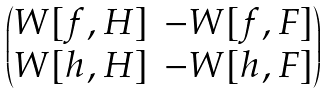<formula> <loc_0><loc_0><loc_500><loc_500>\begin{pmatrix} W [ f , H ] & - W [ f , F ] \\ W [ h , H ] & - W [ h , F ] \end{pmatrix}</formula> 